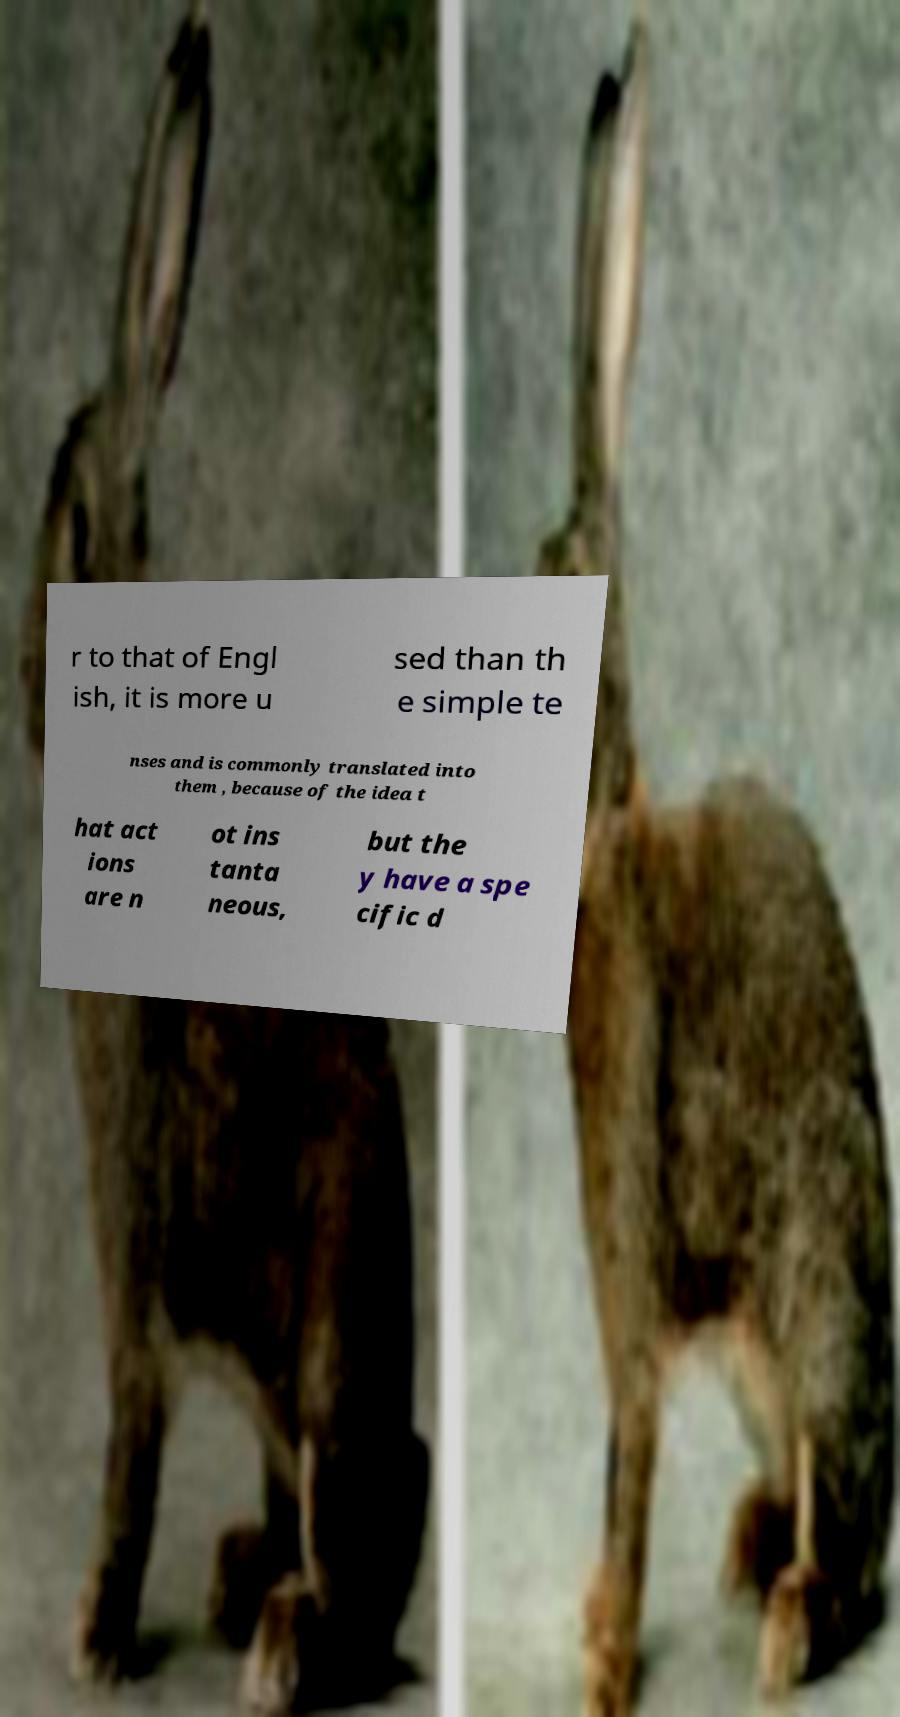Please identify and transcribe the text found in this image. r to that of Engl ish, it is more u sed than th e simple te nses and is commonly translated into them , because of the idea t hat act ions are n ot ins tanta neous, but the y have a spe cific d 